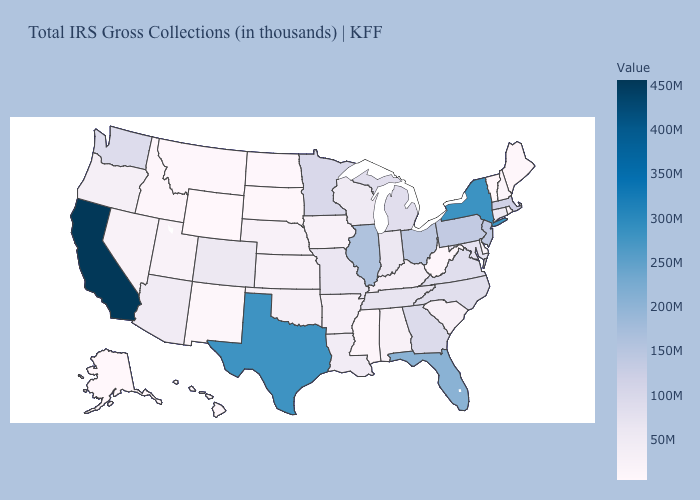Does Maine have a higher value than Illinois?
Be succinct. No. Does North Dakota have the lowest value in the MidWest?
Be succinct. Yes. Which states have the lowest value in the USA?
Concise answer only. Vermont. Which states have the lowest value in the USA?
Short answer required. Vermont. Does the map have missing data?
Write a very short answer. No. Among the states that border Iowa , does South Dakota have the highest value?
Answer briefly. No. 